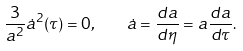<formula> <loc_0><loc_0><loc_500><loc_500>\frac { 3 } { a ^ { 2 } } \dot { a } ^ { 2 } ( \tau ) = 0 , \quad \dot { a } = \frac { d a } { d \eta } = a \frac { d a } { d \tau } .</formula> 